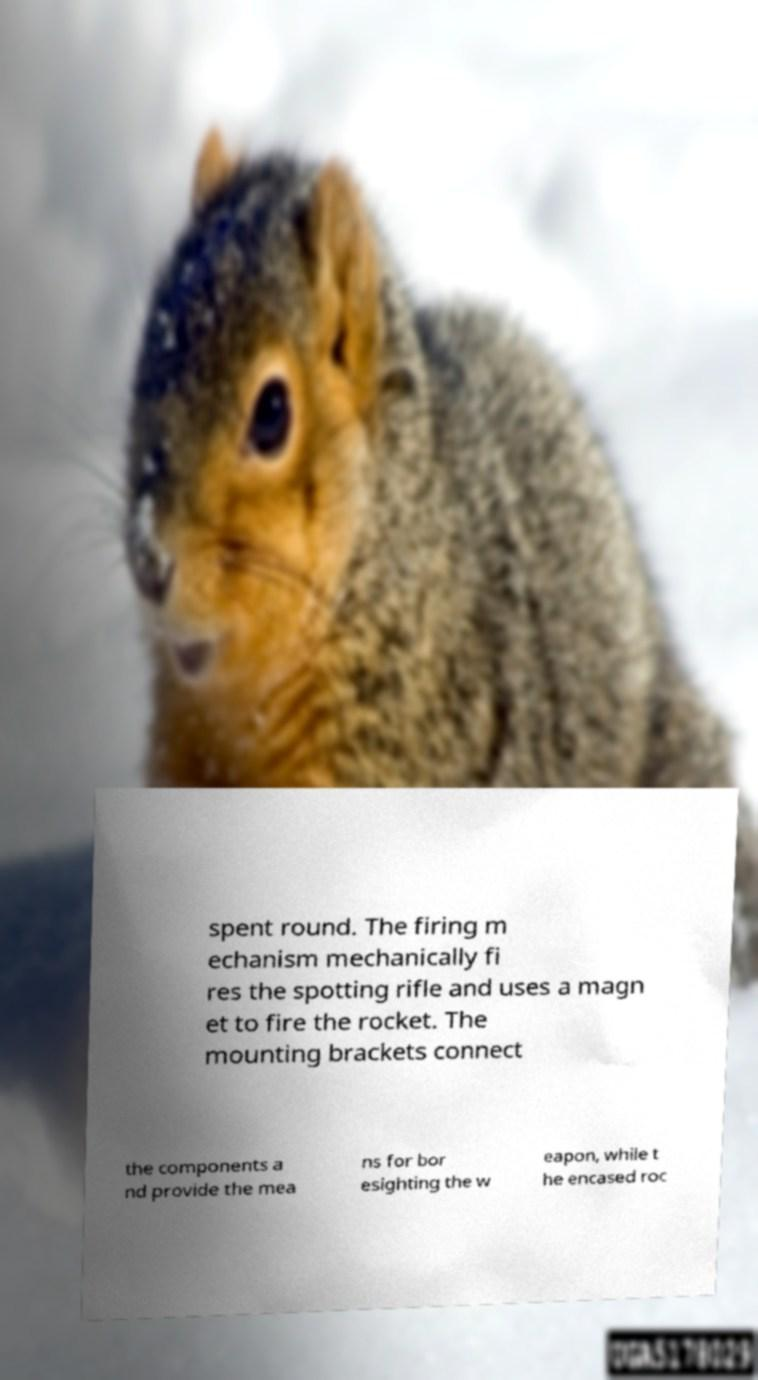For documentation purposes, I need the text within this image transcribed. Could you provide that? spent round. The firing m echanism mechanically fi res the spotting rifle and uses a magn et to fire the rocket. The mounting brackets connect the components a nd provide the mea ns for bor esighting the w eapon, while t he encased roc 